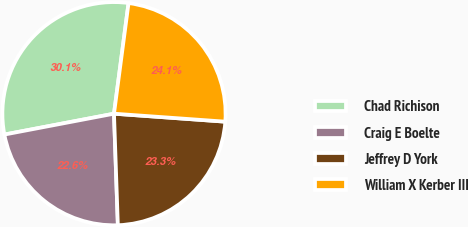<chart> <loc_0><loc_0><loc_500><loc_500><pie_chart><fcel>Chad Richison<fcel>Craig E Boelte<fcel>Jeffrey D York<fcel>William X Kerber III<nl><fcel>30.08%<fcel>22.56%<fcel>23.31%<fcel>24.06%<nl></chart> 